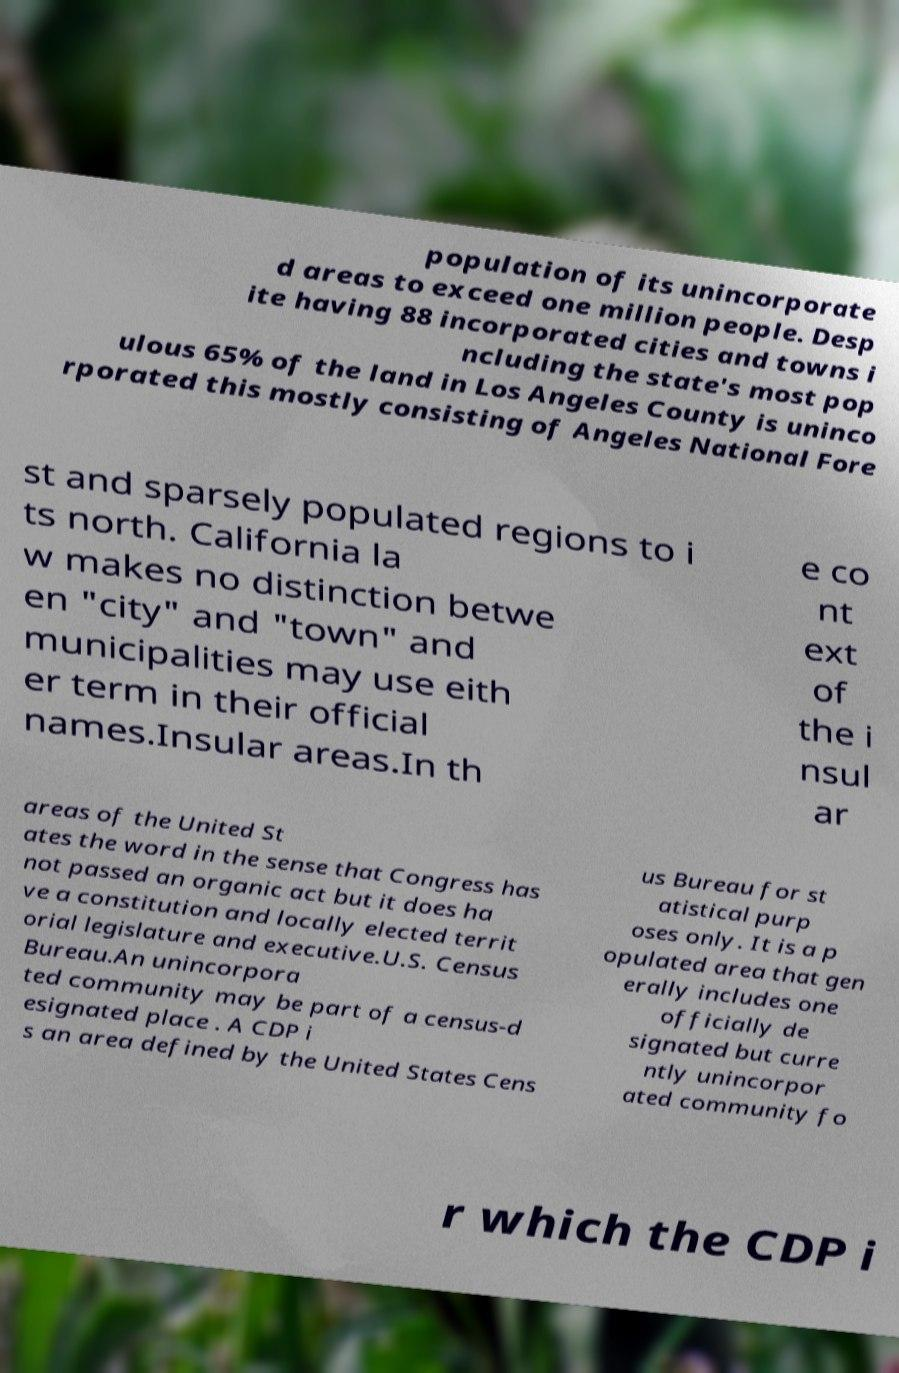For documentation purposes, I need the text within this image transcribed. Could you provide that? population of its unincorporate d areas to exceed one million people. Desp ite having 88 incorporated cities and towns i ncluding the state's most pop ulous 65% of the land in Los Angeles County is uninco rporated this mostly consisting of Angeles National Fore st and sparsely populated regions to i ts north. California la w makes no distinction betwe en "city" and "town" and municipalities may use eith er term in their official names.Insular areas.In th e co nt ext of the i nsul ar areas of the United St ates the word in the sense that Congress has not passed an organic act but it does ha ve a constitution and locally elected territ orial legislature and executive.U.S. Census Bureau.An unincorpora ted community may be part of a census-d esignated place . A CDP i s an area defined by the United States Cens us Bureau for st atistical purp oses only. It is a p opulated area that gen erally includes one officially de signated but curre ntly unincorpor ated community fo r which the CDP i 